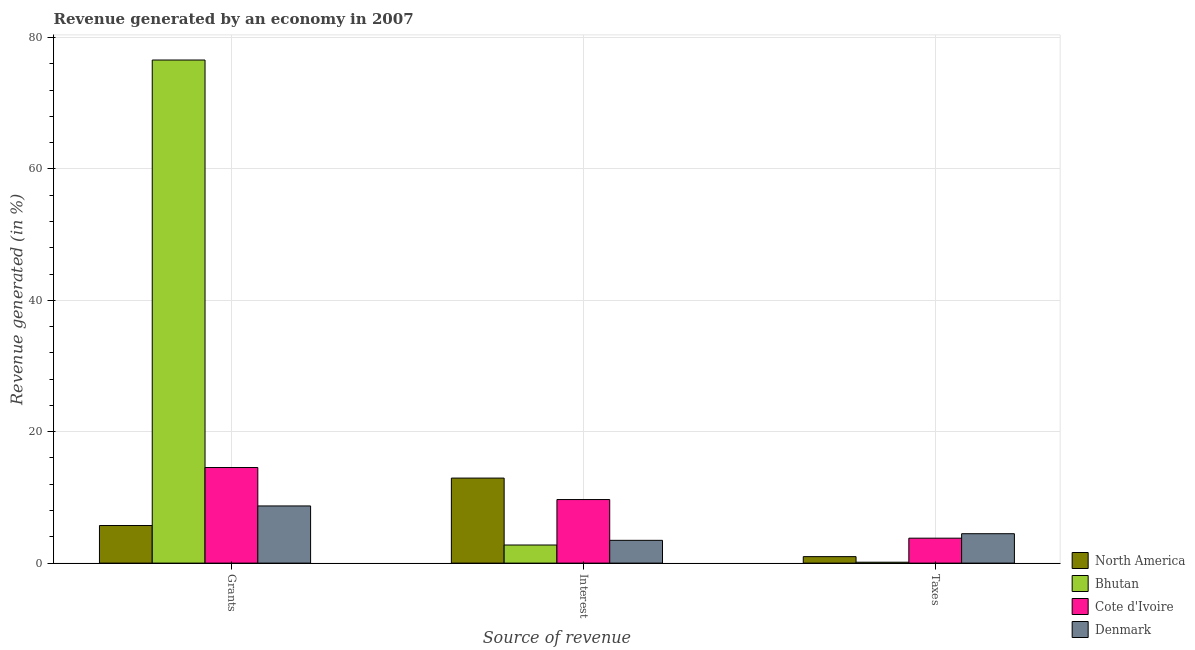Are the number of bars per tick equal to the number of legend labels?
Give a very brief answer. Yes. Are the number of bars on each tick of the X-axis equal?
Your answer should be very brief. Yes. How many bars are there on the 2nd tick from the right?
Offer a very short reply. 4. What is the label of the 3rd group of bars from the left?
Keep it short and to the point. Taxes. What is the percentage of revenue generated by grants in Denmark?
Keep it short and to the point. 8.7. Across all countries, what is the maximum percentage of revenue generated by grants?
Your answer should be compact. 76.57. Across all countries, what is the minimum percentage of revenue generated by interest?
Keep it short and to the point. 2.76. In which country was the percentage of revenue generated by taxes minimum?
Make the answer very short. Bhutan. What is the total percentage of revenue generated by interest in the graph?
Provide a short and direct response. 28.84. What is the difference between the percentage of revenue generated by interest in North America and that in Denmark?
Your response must be concise. 9.47. What is the difference between the percentage of revenue generated by grants in Bhutan and the percentage of revenue generated by taxes in North America?
Provide a short and direct response. 75.58. What is the average percentage of revenue generated by taxes per country?
Keep it short and to the point. 2.35. What is the difference between the percentage of revenue generated by grants and percentage of revenue generated by interest in Denmark?
Your answer should be very brief. 5.23. What is the ratio of the percentage of revenue generated by grants in Cote d'Ivoire to that in North America?
Your response must be concise. 2.54. Is the difference between the percentage of revenue generated by grants in North America and Cote d'Ivoire greater than the difference between the percentage of revenue generated by taxes in North America and Cote d'Ivoire?
Offer a very short reply. No. What is the difference between the highest and the second highest percentage of revenue generated by grants?
Give a very brief answer. 62.02. What is the difference between the highest and the lowest percentage of revenue generated by grants?
Offer a terse response. 70.85. Is the sum of the percentage of revenue generated by taxes in Denmark and Bhutan greater than the maximum percentage of revenue generated by interest across all countries?
Keep it short and to the point. No. What does the 1st bar from the left in Grants represents?
Offer a terse response. North America. Is it the case that in every country, the sum of the percentage of revenue generated by grants and percentage of revenue generated by interest is greater than the percentage of revenue generated by taxes?
Offer a terse response. Yes. How many bars are there?
Offer a very short reply. 12. What is the difference between two consecutive major ticks on the Y-axis?
Offer a very short reply. 20. What is the title of the graph?
Ensure brevity in your answer.  Revenue generated by an economy in 2007. Does "Kiribati" appear as one of the legend labels in the graph?
Provide a succinct answer. No. What is the label or title of the X-axis?
Ensure brevity in your answer.  Source of revenue. What is the label or title of the Y-axis?
Offer a terse response. Revenue generated (in %). What is the Revenue generated (in %) of North America in Grants?
Provide a succinct answer. 5.72. What is the Revenue generated (in %) in Bhutan in Grants?
Give a very brief answer. 76.57. What is the Revenue generated (in %) in Cote d'Ivoire in Grants?
Make the answer very short. 14.55. What is the Revenue generated (in %) of Denmark in Grants?
Give a very brief answer. 8.7. What is the Revenue generated (in %) in North America in Interest?
Make the answer very short. 12.94. What is the Revenue generated (in %) of Bhutan in Interest?
Give a very brief answer. 2.76. What is the Revenue generated (in %) of Cote d'Ivoire in Interest?
Your response must be concise. 9.67. What is the Revenue generated (in %) in Denmark in Interest?
Give a very brief answer. 3.47. What is the Revenue generated (in %) of North America in Taxes?
Your answer should be compact. 0.99. What is the Revenue generated (in %) of Bhutan in Taxes?
Offer a terse response. 0.14. What is the Revenue generated (in %) of Cote d'Ivoire in Taxes?
Your response must be concise. 3.79. What is the Revenue generated (in %) in Denmark in Taxes?
Make the answer very short. 4.47. Across all Source of revenue, what is the maximum Revenue generated (in %) in North America?
Offer a very short reply. 12.94. Across all Source of revenue, what is the maximum Revenue generated (in %) in Bhutan?
Offer a terse response. 76.57. Across all Source of revenue, what is the maximum Revenue generated (in %) in Cote d'Ivoire?
Ensure brevity in your answer.  14.55. Across all Source of revenue, what is the maximum Revenue generated (in %) of Denmark?
Make the answer very short. 8.7. Across all Source of revenue, what is the minimum Revenue generated (in %) in North America?
Make the answer very short. 0.99. Across all Source of revenue, what is the minimum Revenue generated (in %) in Bhutan?
Your answer should be very brief. 0.14. Across all Source of revenue, what is the minimum Revenue generated (in %) in Cote d'Ivoire?
Give a very brief answer. 3.79. Across all Source of revenue, what is the minimum Revenue generated (in %) in Denmark?
Your response must be concise. 3.47. What is the total Revenue generated (in %) of North America in the graph?
Your response must be concise. 19.65. What is the total Revenue generated (in %) of Bhutan in the graph?
Provide a short and direct response. 79.46. What is the total Revenue generated (in %) in Cote d'Ivoire in the graph?
Your response must be concise. 28.02. What is the total Revenue generated (in %) of Denmark in the graph?
Provide a succinct answer. 16.64. What is the difference between the Revenue generated (in %) in North America in Grants and that in Interest?
Make the answer very short. -7.22. What is the difference between the Revenue generated (in %) of Bhutan in Grants and that in Interest?
Your answer should be very brief. 73.81. What is the difference between the Revenue generated (in %) of Cote d'Ivoire in Grants and that in Interest?
Provide a short and direct response. 4.88. What is the difference between the Revenue generated (in %) of Denmark in Grants and that in Interest?
Offer a terse response. 5.23. What is the difference between the Revenue generated (in %) of North America in Grants and that in Taxes?
Your response must be concise. 4.74. What is the difference between the Revenue generated (in %) in Bhutan in Grants and that in Taxes?
Give a very brief answer. 76.43. What is the difference between the Revenue generated (in %) of Cote d'Ivoire in Grants and that in Taxes?
Your answer should be compact. 10.76. What is the difference between the Revenue generated (in %) in Denmark in Grants and that in Taxes?
Your response must be concise. 4.23. What is the difference between the Revenue generated (in %) in North America in Interest and that in Taxes?
Keep it short and to the point. 11.95. What is the difference between the Revenue generated (in %) of Bhutan in Interest and that in Taxes?
Ensure brevity in your answer.  2.62. What is the difference between the Revenue generated (in %) in Cote d'Ivoire in Interest and that in Taxes?
Your answer should be very brief. 5.88. What is the difference between the Revenue generated (in %) in Denmark in Interest and that in Taxes?
Your response must be concise. -1.01. What is the difference between the Revenue generated (in %) of North America in Grants and the Revenue generated (in %) of Bhutan in Interest?
Ensure brevity in your answer.  2.97. What is the difference between the Revenue generated (in %) in North America in Grants and the Revenue generated (in %) in Cote d'Ivoire in Interest?
Make the answer very short. -3.95. What is the difference between the Revenue generated (in %) of North America in Grants and the Revenue generated (in %) of Denmark in Interest?
Your response must be concise. 2.25. What is the difference between the Revenue generated (in %) in Bhutan in Grants and the Revenue generated (in %) in Cote d'Ivoire in Interest?
Offer a terse response. 66.9. What is the difference between the Revenue generated (in %) in Bhutan in Grants and the Revenue generated (in %) in Denmark in Interest?
Keep it short and to the point. 73.1. What is the difference between the Revenue generated (in %) of Cote d'Ivoire in Grants and the Revenue generated (in %) of Denmark in Interest?
Give a very brief answer. 11.08. What is the difference between the Revenue generated (in %) in North America in Grants and the Revenue generated (in %) in Bhutan in Taxes?
Offer a terse response. 5.58. What is the difference between the Revenue generated (in %) of North America in Grants and the Revenue generated (in %) of Cote d'Ivoire in Taxes?
Ensure brevity in your answer.  1.93. What is the difference between the Revenue generated (in %) of North America in Grants and the Revenue generated (in %) of Denmark in Taxes?
Your answer should be very brief. 1.25. What is the difference between the Revenue generated (in %) of Bhutan in Grants and the Revenue generated (in %) of Cote d'Ivoire in Taxes?
Keep it short and to the point. 72.78. What is the difference between the Revenue generated (in %) in Bhutan in Grants and the Revenue generated (in %) in Denmark in Taxes?
Ensure brevity in your answer.  72.1. What is the difference between the Revenue generated (in %) of Cote d'Ivoire in Grants and the Revenue generated (in %) of Denmark in Taxes?
Your answer should be compact. 10.08. What is the difference between the Revenue generated (in %) of North America in Interest and the Revenue generated (in %) of Bhutan in Taxes?
Your answer should be compact. 12.8. What is the difference between the Revenue generated (in %) in North America in Interest and the Revenue generated (in %) in Cote d'Ivoire in Taxes?
Ensure brevity in your answer.  9.15. What is the difference between the Revenue generated (in %) of North America in Interest and the Revenue generated (in %) of Denmark in Taxes?
Offer a very short reply. 8.47. What is the difference between the Revenue generated (in %) in Bhutan in Interest and the Revenue generated (in %) in Cote d'Ivoire in Taxes?
Your response must be concise. -1.04. What is the difference between the Revenue generated (in %) of Bhutan in Interest and the Revenue generated (in %) of Denmark in Taxes?
Your answer should be compact. -1.72. What is the difference between the Revenue generated (in %) of Cote d'Ivoire in Interest and the Revenue generated (in %) of Denmark in Taxes?
Ensure brevity in your answer.  5.2. What is the average Revenue generated (in %) in North America per Source of revenue?
Offer a very short reply. 6.55. What is the average Revenue generated (in %) in Bhutan per Source of revenue?
Provide a succinct answer. 26.49. What is the average Revenue generated (in %) in Cote d'Ivoire per Source of revenue?
Your answer should be very brief. 9.34. What is the average Revenue generated (in %) of Denmark per Source of revenue?
Provide a short and direct response. 5.55. What is the difference between the Revenue generated (in %) in North America and Revenue generated (in %) in Bhutan in Grants?
Ensure brevity in your answer.  -70.85. What is the difference between the Revenue generated (in %) in North America and Revenue generated (in %) in Cote d'Ivoire in Grants?
Ensure brevity in your answer.  -8.83. What is the difference between the Revenue generated (in %) of North America and Revenue generated (in %) of Denmark in Grants?
Offer a very short reply. -2.98. What is the difference between the Revenue generated (in %) of Bhutan and Revenue generated (in %) of Cote d'Ivoire in Grants?
Offer a terse response. 62.02. What is the difference between the Revenue generated (in %) in Bhutan and Revenue generated (in %) in Denmark in Grants?
Ensure brevity in your answer.  67.87. What is the difference between the Revenue generated (in %) in Cote d'Ivoire and Revenue generated (in %) in Denmark in Grants?
Give a very brief answer. 5.85. What is the difference between the Revenue generated (in %) in North America and Revenue generated (in %) in Bhutan in Interest?
Your answer should be very brief. 10.18. What is the difference between the Revenue generated (in %) of North America and Revenue generated (in %) of Cote d'Ivoire in Interest?
Your answer should be compact. 3.27. What is the difference between the Revenue generated (in %) in North America and Revenue generated (in %) in Denmark in Interest?
Provide a succinct answer. 9.47. What is the difference between the Revenue generated (in %) of Bhutan and Revenue generated (in %) of Cote d'Ivoire in Interest?
Your answer should be compact. -6.92. What is the difference between the Revenue generated (in %) of Bhutan and Revenue generated (in %) of Denmark in Interest?
Ensure brevity in your answer.  -0.71. What is the difference between the Revenue generated (in %) in Cote d'Ivoire and Revenue generated (in %) in Denmark in Interest?
Offer a terse response. 6.21. What is the difference between the Revenue generated (in %) of North America and Revenue generated (in %) of Bhutan in Taxes?
Your answer should be very brief. 0.85. What is the difference between the Revenue generated (in %) of North America and Revenue generated (in %) of Cote d'Ivoire in Taxes?
Your answer should be compact. -2.81. What is the difference between the Revenue generated (in %) in North America and Revenue generated (in %) in Denmark in Taxes?
Make the answer very short. -3.49. What is the difference between the Revenue generated (in %) in Bhutan and Revenue generated (in %) in Cote d'Ivoire in Taxes?
Make the answer very short. -3.66. What is the difference between the Revenue generated (in %) of Bhutan and Revenue generated (in %) of Denmark in Taxes?
Give a very brief answer. -4.34. What is the difference between the Revenue generated (in %) in Cote d'Ivoire and Revenue generated (in %) in Denmark in Taxes?
Give a very brief answer. -0.68. What is the ratio of the Revenue generated (in %) of North America in Grants to that in Interest?
Offer a terse response. 0.44. What is the ratio of the Revenue generated (in %) of Bhutan in Grants to that in Interest?
Provide a short and direct response. 27.78. What is the ratio of the Revenue generated (in %) of Cote d'Ivoire in Grants to that in Interest?
Provide a succinct answer. 1.5. What is the ratio of the Revenue generated (in %) of Denmark in Grants to that in Interest?
Your answer should be compact. 2.51. What is the ratio of the Revenue generated (in %) of North America in Grants to that in Taxes?
Make the answer very short. 5.8. What is the ratio of the Revenue generated (in %) in Bhutan in Grants to that in Taxes?
Your response must be concise. 558.49. What is the ratio of the Revenue generated (in %) of Cote d'Ivoire in Grants to that in Taxes?
Offer a terse response. 3.83. What is the ratio of the Revenue generated (in %) of Denmark in Grants to that in Taxes?
Offer a very short reply. 1.94. What is the ratio of the Revenue generated (in %) in North America in Interest to that in Taxes?
Provide a succinct answer. 13.11. What is the ratio of the Revenue generated (in %) of Bhutan in Interest to that in Taxes?
Provide a succinct answer. 20.1. What is the ratio of the Revenue generated (in %) in Cote d'Ivoire in Interest to that in Taxes?
Provide a short and direct response. 2.55. What is the ratio of the Revenue generated (in %) in Denmark in Interest to that in Taxes?
Provide a succinct answer. 0.78. What is the difference between the highest and the second highest Revenue generated (in %) of North America?
Offer a very short reply. 7.22. What is the difference between the highest and the second highest Revenue generated (in %) in Bhutan?
Offer a very short reply. 73.81. What is the difference between the highest and the second highest Revenue generated (in %) of Cote d'Ivoire?
Your answer should be very brief. 4.88. What is the difference between the highest and the second highest Revenue generated (in %) in Denmark?
Provide a succinct answer. 4.23. What is the difference between the highest and the lowest Revenue generated (in %) of North America?
Keep it short and to the point. 11.95. What is the difference between the highest and the lowest Revenue generated (in %) in Bhutan?
Offer a very short reply. 76.43. What is the difference between the highest and the lowest Revenue generated (in %) in Cote d'Ivoire?
Offer a very short reply. 10.76. What is the difference between the highest and the lowest Revenue generated (in %) in Denmark?
Provide a short and direct response. 5.23. 